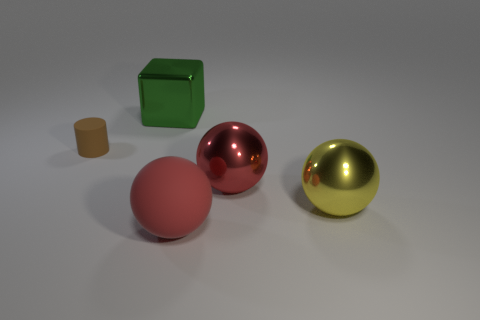What number of other things are there of the same color as the matte cylinder? There are no other objects of the exact same matte finish and color as the matte cylinder. 